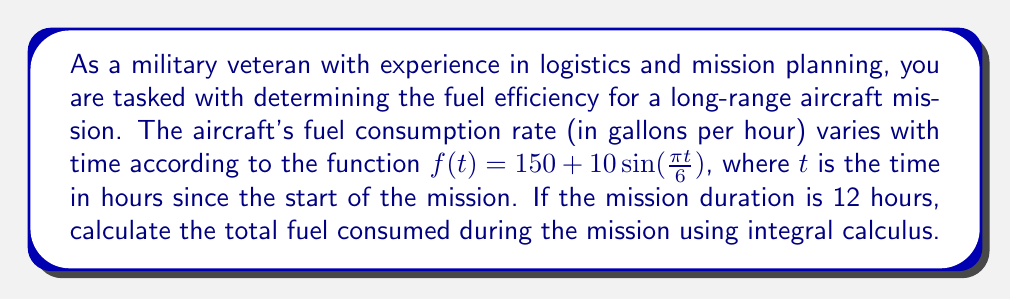Help me with this question. To solve this problem, we need to integrate the fuel consumption rate function over the given time interval. Here's a step-by-step approach:

1. The fuel consumption rate is given by $f(t) = 150 + 10\sin(\frac{\pi t}{6})$.

2. We need to find the total fuel consumed over 12 hours, which means integrating from $t=0$ to $t=12$.

3. Set up the definite integral:

   $$\int_0^{12} (150 + 10\sin(\frac{\pi t}{6})) dt$$

4. Split the integral into two parts:

   $$\int_0^{12} 150 dt + \int_0^{12} 10\sin(\frac{\pi t}{6}) dt$$

5. Evaluate the first part:

   $$150t \bigg|_0^{12} = 150 \cdot 12 - 150 \cdot 0 = 1800$$

6. For the second part, use the substitution method:
   Let $u = \frac{\pi t}{6}$, then $du = \frac{\pi}{6} dt$ or $dt = \frac{6}{\pi} du$

   New limits: when $t=0$, $u=0$; when $t=12$, $u=2\pi$

   $$10 \cdot \frac{6}{\pi} \int_0^{2\pi} \sin(u) du = -\frac{60}{\pi} \cos(u) \bigg|_0^{2\pi} = -\frac{60}{\pi} (\cos(2\pi) - \cos(0)) = 0$$

7. Sum the results from steps 5 and 6:

   Total fuel consumed = $1800 + 0 = 1800$ gallons
Answer: The total fuel consumed during the 12-hour mission is 1800 gallons. 